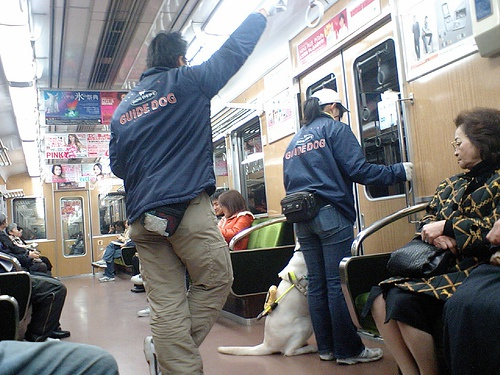Describe the objects in this image and their specific colors. I can see people in white, gray, blue, navy, and black tones, people in white, black, gray, and maroon tones, people in white, black, navy, blue, and gray tones, bench in white, black, and gray tones, and bench in white, black, olive, gray, and maroon tones in this image. 